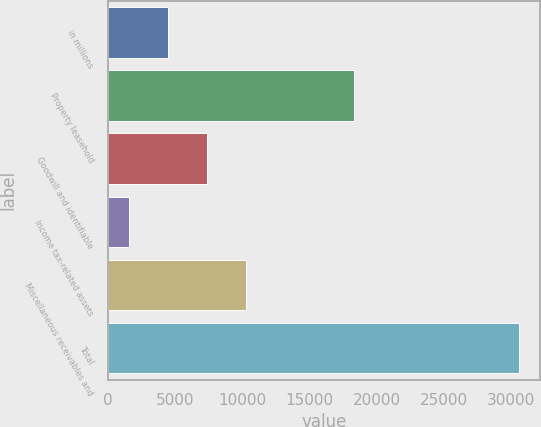<chart> <loc_0><loc_0><loc_500><loc_500><bar_chart><fcel>in millions<fcel>Property leasehold<fcel>Goodwill and identifiable<fcel>Income tax-related assets<fcel>Miscellaneous receivables and<fcel>Total<nl><fcel>4440.1<fcel>18317<fcel>7351.2<fcel>1529<fcel>10262.3<fcel>30640<nl></chart> 